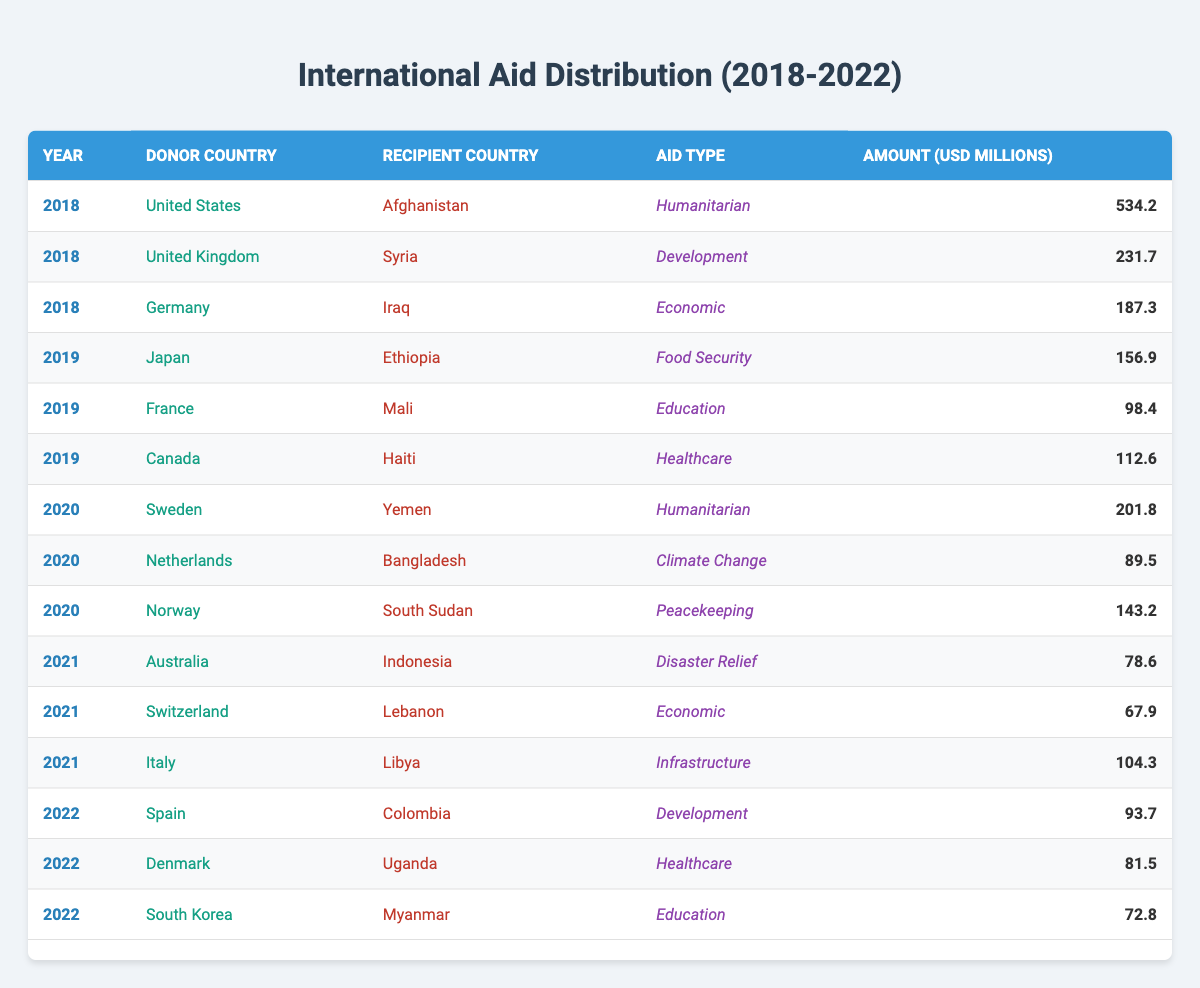What is the total amount of aid provided by the United States in 2018? In the table, I search for rows where the "Donor Country" is "United States" and the "Year" is "2018". I find that in 2018, the United States provided 534.2 million USD in aid to Afghanistan. This is the only entry for the United States in that year, so the total amount is simply 534.2 million USD.
Answer: 534.2 million USD Which country received the most aid in 2019? I review each row for the year 2019 and list the amounts provided to each recipient country. Japan provided 156.9 million USD to Ethiopia, Canada provided 112.6 million USD to Haiti, and France provided 98.4 million USD to Mali. Since 156.9 million USD is the highest amount among these, the recipient country that received the most aid in 2019 is Ethiopia.
Answer: Ethiopia Is it true that South Korea provided aid in 2022? A quick scan of the table for the year 2022 shows that South Korea appears as a donor country. The table indicates that South Korea provided aid to Myanmar in 2022. Therefore, the statement is true.
Answer: Yes What was the total aid amount distributed by Sweden and Norway in 2020? I look for rows with the year 2020 for both Sweden and Norway. Sweden provided 201.8 million USD to Yemen, while Norway provided 143.2 million USD to South Sudan. I then sum these amounts: 201.8 + 143.2 = 345 million USD. Thus, the total aid amount from both countries in 2020 is 345 million USD.
Answer: 345 million USD How does the aid distribution pattern differ between 2021 and 2022? I analyze the data for both years by identifying the number of unique donor countries and the total amount of aid provided in each year. In 2021, there are three donors (Australia, Switzerland, Italy) with amounts totaling around 250.8 million USD. In 2022, there are three different donors (Spain, Denmark, South Korea) providing a total of 248 million USD. I conclude that the total aid amounts were similar despite different countries being involved, indicating a consistent level of support across these years.
Answer: Similar aid distribution with consistent support levels What types of aid were provided to Uganda? I search through the data for mentions of Uganda as a recipient country. The only relevant row I find states that Denmark provided healthcare aid in 2022. Therefore, the type of aid provided to Uganda was healthcare.
Answer: Healthcare 